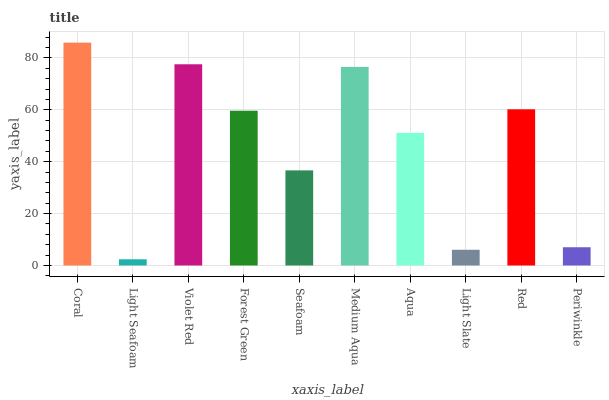Is Light Seafoam the minimum?
Answer yes or no. Yes. Is Coral the maximum?
Answer yes or no. Yes. Is Violet Red the minimum?
Answer yes or no. No. Is Violet Red the maximum?
Answer yes or no. No. Is Violet Red greater than Light Seafoam?
Answer yes or no. Yes. Is Light Seafoam less than Violet Red?
Answer yes or no. Yes. Is Light Seafoam greater than Violet Red?
Answer yes or no. No. Is Violet Red less than Light Seafoam?
Answer yes or no. No. Is Forest Green the high median?
Answer yes or no. Yes. Is Aqua the low median?
Answer yes or no. Yes. Is Light Slate the high median?
Answer yes or no. No. Is Red the low median?
Answer yes or no. No. 